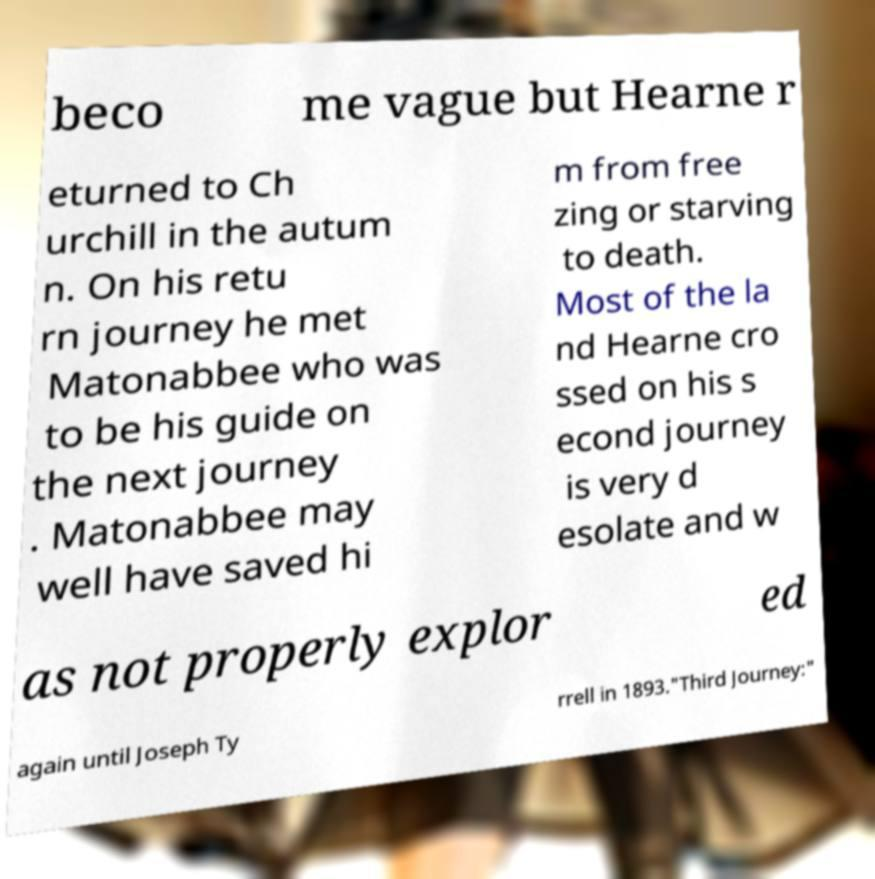Please identify and transcribe the text found in this image. beco me vague but Hearne r eturned to Ch urchill in the autum n. On his retu rn journey he met Matonabbee who was to be his guide on the next journey . Matonabbee may well have saved hi m from free zing or starving to death. Most of the la nd Hearne cro ssed on his s econd journey is very d esolate and w as not properly explor ed again until Joseph Ty rrell in 1893."Third Journey:" 